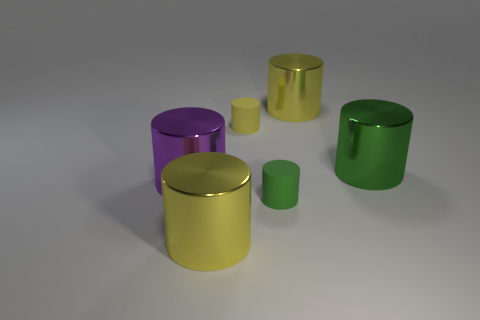How many things are either yellow things or big green cylinders?
Your answer should be very brief. 4. Is the shape of the rubber object in front of the large green metal object the same as the shiny thing in front of the purple metallic cylinder?
Offer a very short reply. Yes. How many green cylinders are both in front of the purple metal cylinder and right of the small green matte cylinder?
Give a very brief answer. 0. How many other objects are the same size as the green shiny cylinder?
Ensure brevity in your answer.  3. There is a thing that is both to the right of the tiny green matte thing and in front of the tiny yellow thing; what material is it made of?
Ensure brevity in your answer.  Metal. The green metal thing that is the same shape as the large purple shiny thing is what size?
Your answer should be very brief. Large. The thing that is both to the right of the green rubber thing and left of the green shiny cylinder has what shape?
Offer a very short reply. Cylinder. There is a yellow matte thing; is its size the same as the green thing that is in front of the purple metallic object?
Offer a very short reply. Yes. There is another tiny matte object that is the same shape as the small green rubber object; what color is it?
Provide a succinct answer. Yellow. There is a yellow shiny cylinder that is behind the small green rubber thing; is its size the same as the rubber object that is in front of the big green thing?
Provide a short and direct response. No. 